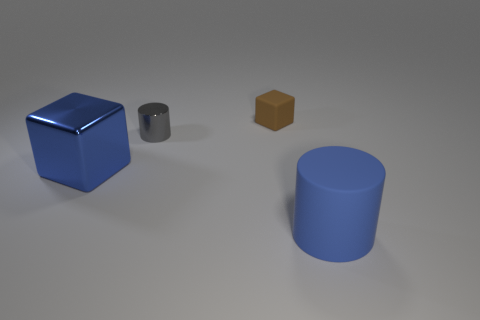What number of small matte blocks are in front of the brown rubber cube that is on the right side of the metallic cylinder?
Provide a short and direct response. 0. There is a matte cube; are there any big objects left of it?
Your answer should be very brief. Yes. Is the shape of the large object that is on the left side of the small matte cube the same as  the small gray thing?
Keep it short and to the point. No. What material is the thing that is the same color as the metallic cube?
Your answer should be compact. Rubber. How many large blocks are the same color as the big matte cylinder?
Your answer should be very brief. 1. What is the shape of the blue thing to the right of the large blue object on the left side of the metallic cylinder?
Offer a very short reply. Cylinder. Are there any brown matte objects of the same shape as the small metal object?
Offer a terse response. No. There is a tiny cube; is its color the same as the large object that is left of the small metallic cylinder?
Ensure brevity in your answer.  No. The matte cylinder that is the same color as the metallic cube is what size?
Give a very brief answer. Large. Are there any blue matte cubes that have the same size as the matte cylinder?
Provide a succinct answer. No. 